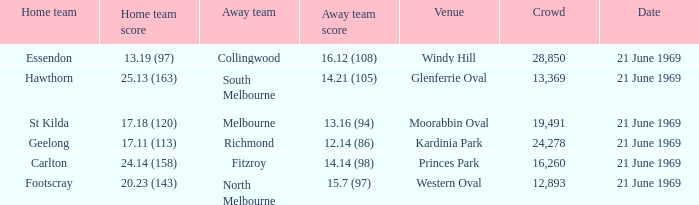When was there a game at Kardinia Park? 21 June 1969. 